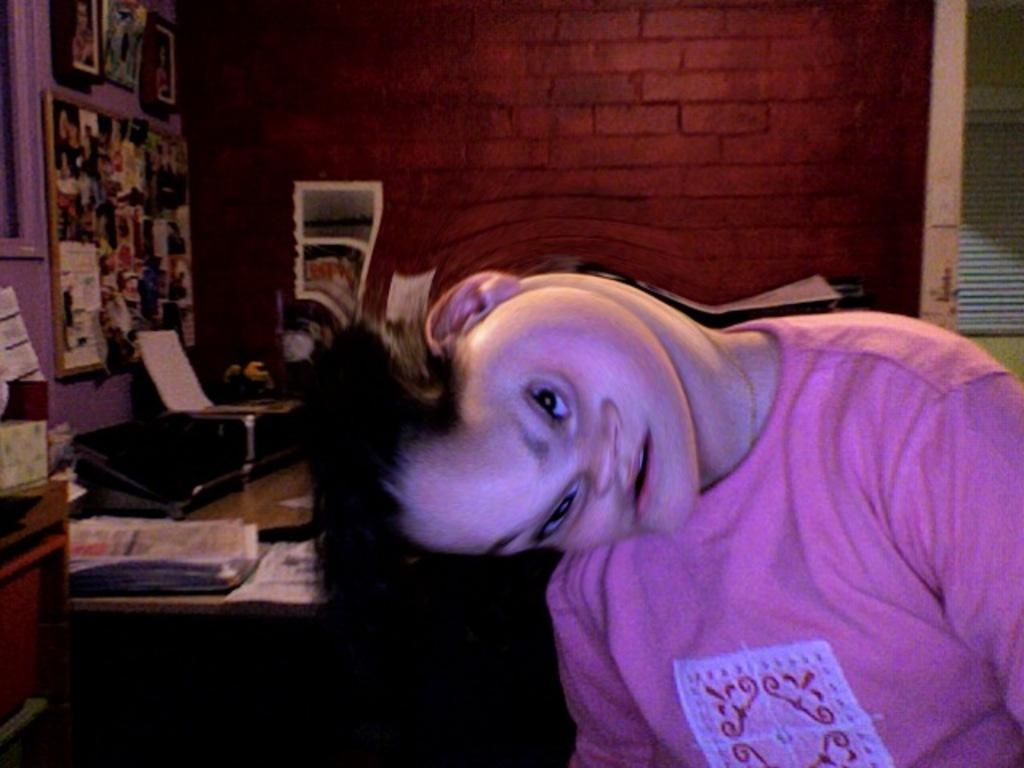What is the main subject in the image? There is a person in the image. What items can be seen near the person? There are papers, a cupboard, a board, frames, a flower vase, and posters in the image. What is the background of the image? There is a wall in the background of the image. What type of acoustics can be heard in the image? There is no information about sound or acoustics in the image, so it cannot be determined. Can you see a hook in the image? There is no mention of a hook in the image, so it cannot be confirmed. 